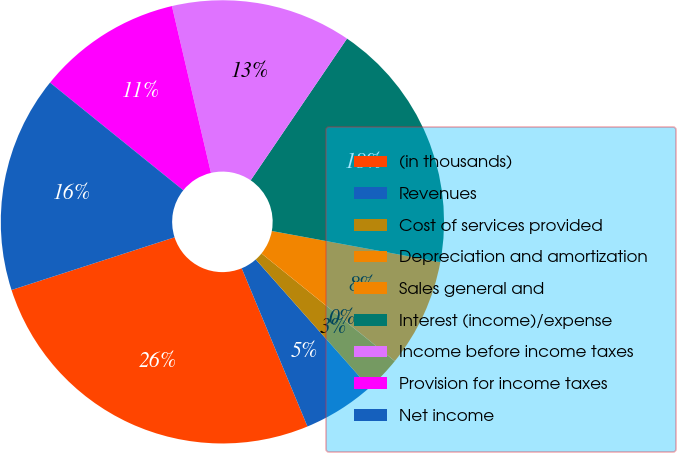Convert chart. <chart><loc_0><loc_0><loc_500><loc_500><pie_chart><fcel>(in thousands)<fcel>Revenues<fcel>Cost of services provided<fcel>Depreciation and amortization<fcel>Sales general and<fcel>Interest (income)/expense<fcel>Income before income taxes<fcel>Provision for income taxes<fcel>Net income<nl><fcel>26.3%<fcel>5.27%<fcel>2.64%<fcel>0.01%<fcel>7.9%<fcel>18.41%<fcel>13.16%<fcel>10.53%<fcel>15.79%<nl></chart> 